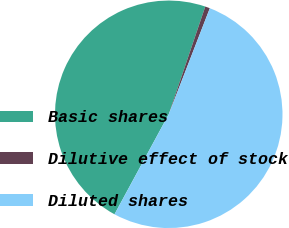Convert chart to OTSL. <chart><loc_0><loc_0><loc_500><loc_500><pie_chart><fcel>Basic shares<fcel>Dilutive effect of stock<fcel>Diluted shares<nl><fcel>47.3%<fcel>0.68%<fcel>52.03%<nl></chart> 